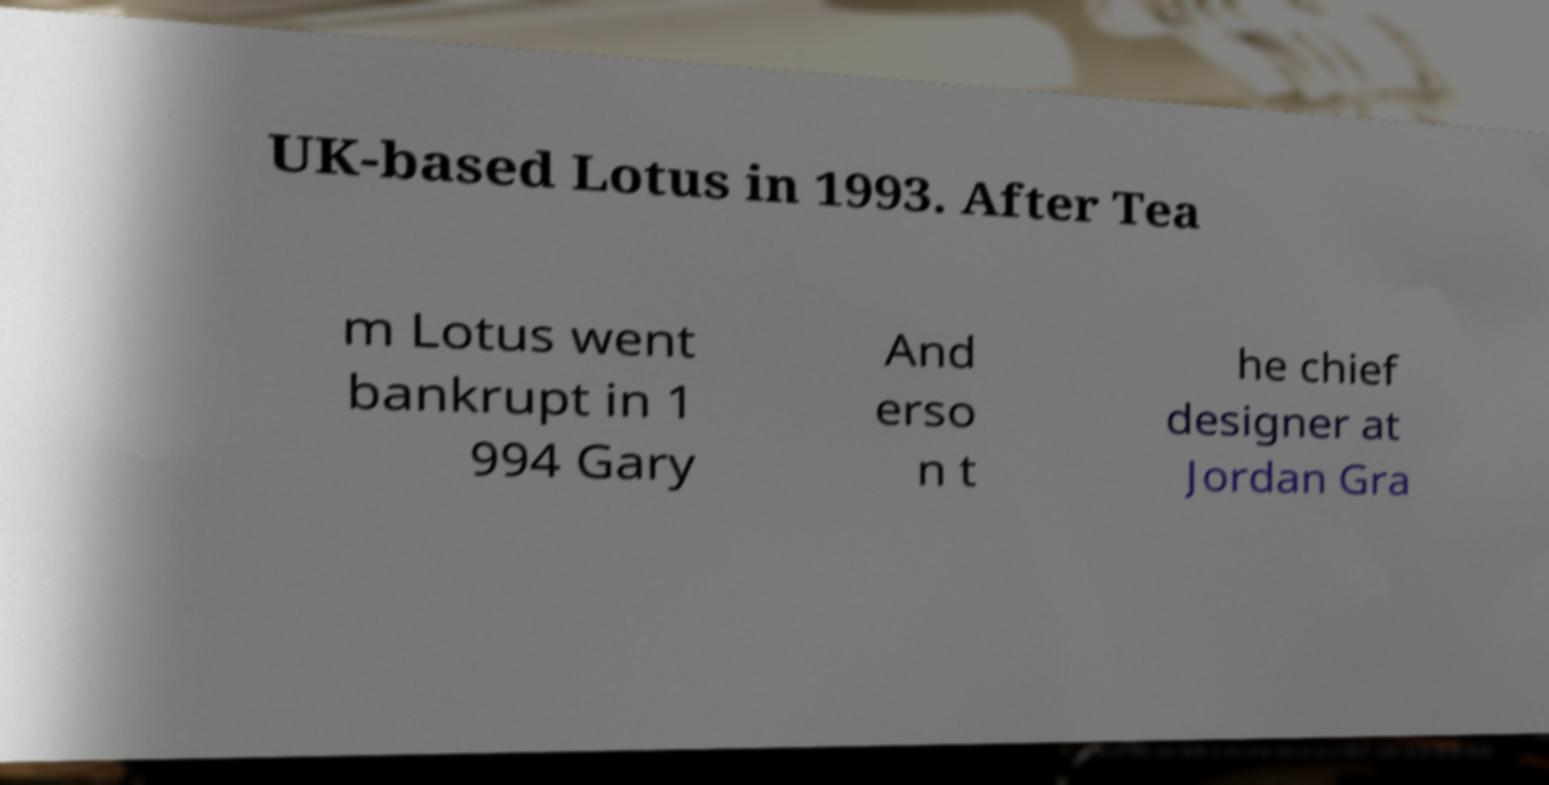For documentation purposes, I need the text within this image transcribed. Could you provide that? UK-based Lotus in 1993. After Tea m Lotus went bankrupt in 1 994 Gary And erso n t he chief designer at Jordan Gra 